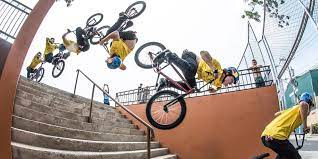What trick might the cyclist be performing in the picture? The cyclist appears to be performing a stair jump, which may include a trick like a 360-degree spin or a tailwhip. Such a trick requires precision, timing, and confidence. 